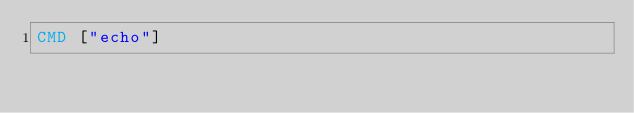<code> <loc_0><loc_0><loc_500><loc_500><_Dockerfile_>CMD ["echo"]
</code> 